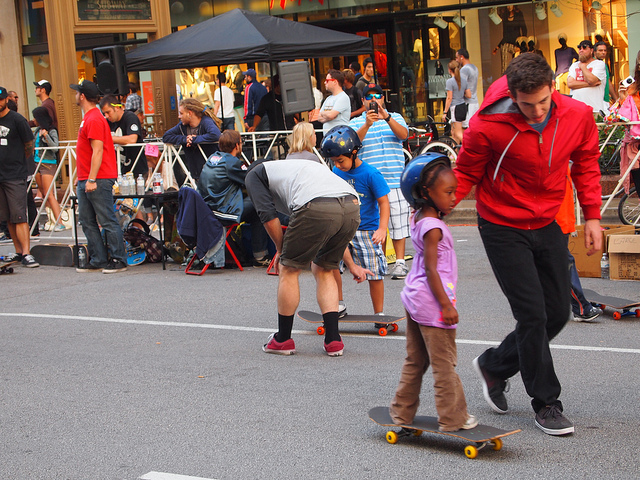<image>Are the people in the foreground a couple? It is uncertain if the people in the foreground are a couple. The answer could be either yes or no. Are the people in the foreground a couple? I don't know if the people in the foreground are a couple. It is uncertain. 